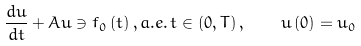<formula> <loc_0><loc_0><loc_500><loc_500>\frac { d u } { d t } + A u \ni f _ { 0 } \left ( t \right ) , a . e . \, t \in \left ( 0 , T \right ) , \, \quad \, u \left ( 0 \right ) = u _ { 0 }</formula> 